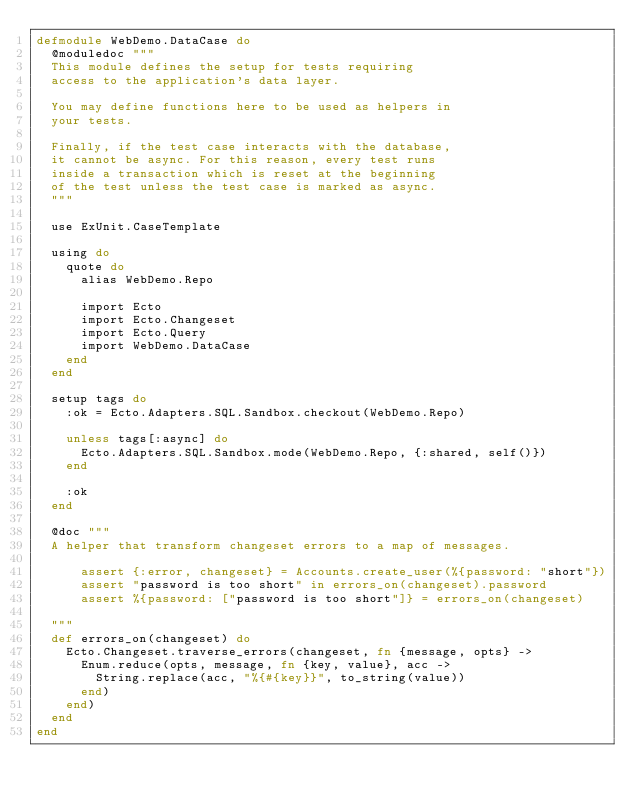<code> <loc_0><loc_0><loc_500><loc_500><_Elixir_>defmodule WebDemo.DataCase do
  @moduledoc """
  This module defines the setup for tests requiring
  access to the application's data layer.

  You may define functions here to be used as helpers in
  your tests.

  Finally, if the test case interacts with the database,
  it cannot be async. For this reason, every test runs
  inside a transaction which is reset at the beginning
  of the test unless the test case is marked as async.
  """

  use ExUnit.CaseTemplate

  using do
    quote do
      alias WebDemo.Repo

      import Ecto
      import Ecto.Changeset
      import Ecto.Query
      import WebDemo.DataCase
    end
  end

  setup tags do
    :ok = Ecto.Adapters.SQL.Sandbox.checkout(WebDemo.Repo)

    unless tags[:async] do
      Ecto.Adapters.SQL.Sandbox.mode(WebDemo.Repo, {:shared, self()})
    end

    :ok
  end

  @doc """
  A helper that transform changeset errors to a map of messages.

      assert {:error, changeset} = Accounts.create_user(%{password: "short"})
      assert "password is too short" in errors_on(changeset).password
      assert %{password: ["password is too short"]} = errors_on(changeset)

  """
  def errors_on(changeset) do
    Ecto.Changeset.traverse_errors(changeset, fn {message, opts} ->
      Enum.reduce(opts, message, fn {key, value}, acc ->
        String.replace(acc, "%{#{key}}", to_string(value))
      end)
    end)
  end
end
</code> 